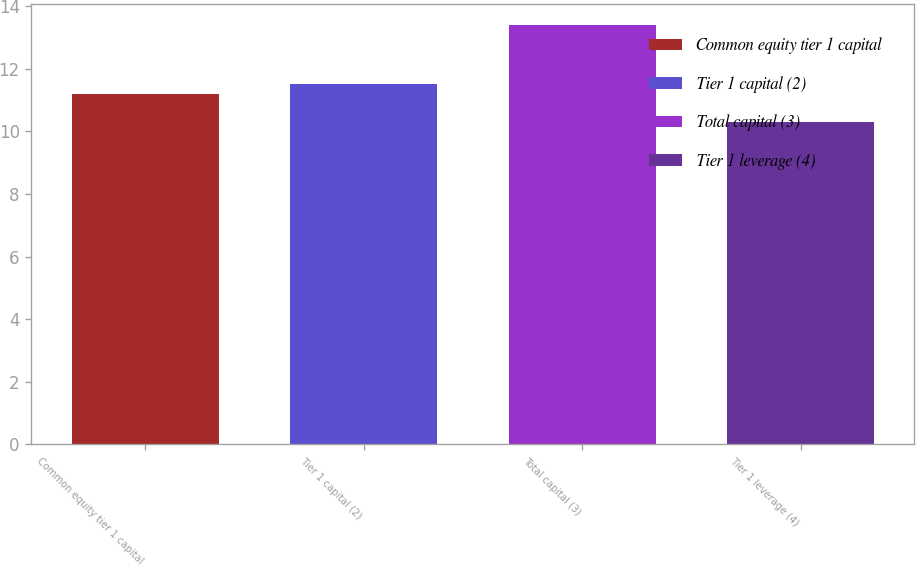Convert chart to OTSL. <chart><loc_0><loc_0><loc_500><loc_500><bar_chart><fcel>Common equity tier 1 capital<fcel>Tier 1 capital (2)<fcel>Total capital (3)<fcel>Tier 1 leverage (4)<nl><fcel>11.2<fcel>11.51<fcel>13.4<fcel>10.3<nl></chart> 